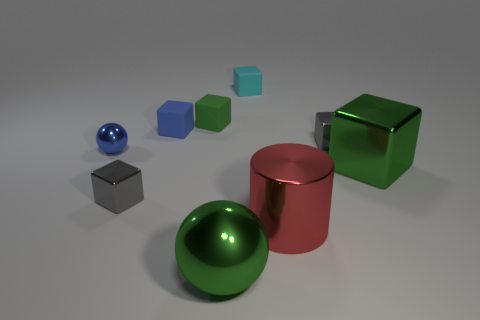Is there a large gray block?
Offer a terse response. No. Are the large green sphere that is right of the tiny sphere and the large cube in front of the tiny blue cube made of the same material?
Your answer should be very brief. Yes. How big is the gray shiny cube that is behind the tiny gray metal block left of the green metallic object on the left side of the cyan block?
Your answer should be compact. Small. How many red cylinders are the same material as the small cyan thing?
Give a very brief answer. 0. Is the number of large gray balls less than the number of cylinders?
Make the answer very short. Yes. What size is the cyan object that is the same shape as the small green thing?
Ensure brevity in your answer.  Small. Are the thing that is in front of the cylinder and the large cylinder made of the same material?
Offer a terse response. Yes. Is the shape of the green matte thing the same as the cyan thing?
Make the answer very short. Yes. What number of things are shiny blocks behind the small blue metallic thing or gray matte spheres?
Your answer should be very brief. 1. What size is the blue block that is made of the same material as the tiny cyan cube?
Give a very brief answer. Small. 